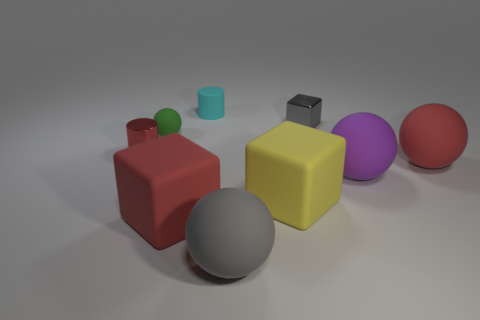What number of other objects are there of the same color as the small metal cylinder?
Your response must be concise. 2. How many other things are made of the same material as the small red thing?
Your answer should be very brief. 1. Does the cylinder on the left side of the small green matte sphere have the same material as the large purple ball?
Provide a short and direct response. No. There is a block behind the small red metal object; what is it made of?
Keep it short and to the point. Metal. There is a cyan rubber cylinder that is behind the rubber cube that is left of the large gray thing; how big is it?
Offer a very short reply. Small. How many metal blocks are the same size as the cyan matte cylinder?
Make the answer very short. 1. There is a tiny metal object that is to the left of the small gray block; is it the same color as the big rubber object that is on the left side of the tiny cyan matte cylinder?
Make the answer very short. Yes. Are there any tiny red objects in front of the red block?
Offer a very short reply. No. There is a sphere that is to the left of the tiny gray shiny thing and behind the yellow matte block; what color is it?
Provide a short and direct response. Green. Are there any large things that have the same color as the metallic cylinder?
Offer a very short reply. Yes. 